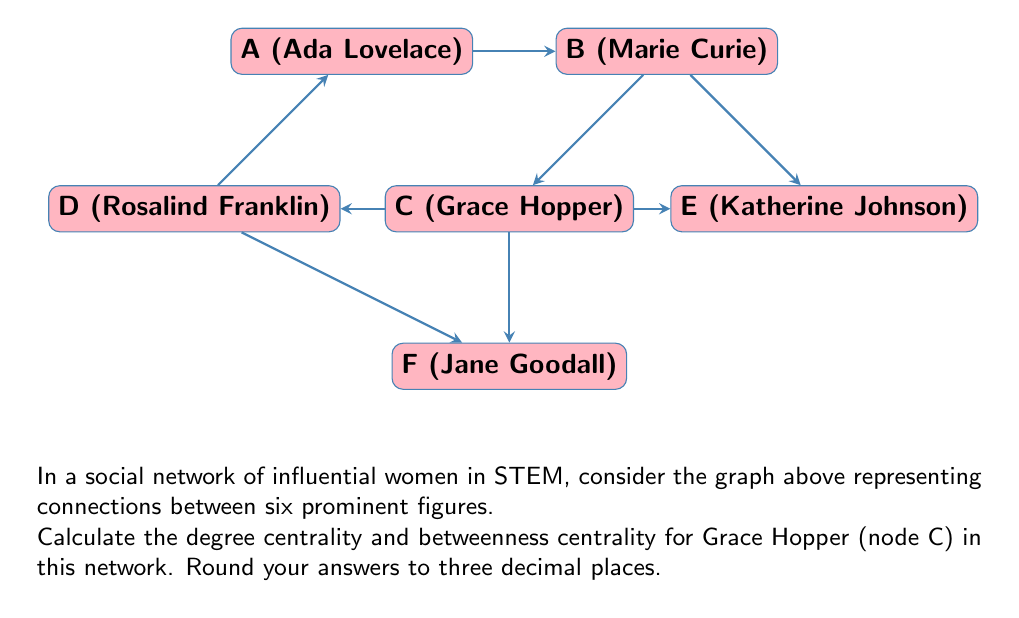Give your solution to this math problem. To solve this problem, we need to calculate two centrality measures for Grace Hopper (node C):

1. Degree Centrality:
Degree centrality is the number of direct connections a node has, normalized by the maximum possible connections.

For node C (Grace Hopper):
- Direct connections: 4 (to A, B, E, and F)
- Total nodes in the network: 6
- Maximum possible connections: 5 (n-1, where n is the total number of nodes)

Degree Centrality = $\frac{\text{Number of connections}}{\text{Maximum possible connections}} = \frac{4}{5} = 0.800$

2. Betweenness Centrality:
Betweenness centrality measures how often a node appears on the shortest paths between other nodes.

First, we need to count the number of shortest paths that pass through node C:

- A to E: A-B-E and A-C-E (1/2 path through C)
- A to F: A-C-F and A-D-F (1/2 path through C)
- B to D: B-A-D and B-C-D (1/2 path through C)
- B to F: B-C-F (1 path through C)
- D to E: D-C-E (1 path through C)

Total: 1/2 + 1/2 + 1/2 + 1 + 1 = 3.5

Now, we normalize this value by the maximum possible betweenness:

Maximum betweenness = $\frac{(n-1)(n-2)}{2} = \frac{(6-1)(6-2)}{2} = 10$

Betweenness Centrality = $\frac{3.5}{10} = 0.350$

Therefore, the degree centrality for Grace Hopper is 0.800, and the betweenness centrality is 0.350.
Answer: Degree Centrality: 0.800, Betweenness Centrality: 0.350 